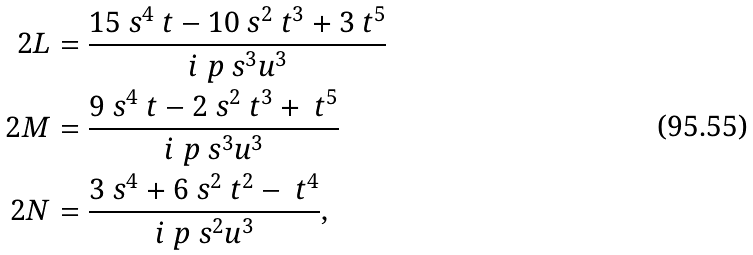Convert formula to latex. <formula><loc_0><loc_0><loc_500><loc_500>\ 2 L & = \frac { 1 5 \ s ^ { 4 } \ t - 1 0 \ s ^ { 2 } \ t ^ { 3 } + 3 \ t ^ { 5 } } { i \ p \ s ^ { 3 } u ^ { 3 } } \\ \ 2 M & = \frac { 9 \ s ^ { 4 } \ t - 2 \ s ^ { 2 } \ t ^ { 3 } + \ t ^ { 5 } } { i \ p \ s ^ { 3 } u ^ { 3 } } \\ \ 2 N & = \frac { 3 \ s ^ { 4 } + 6 \ s ^ { 2 } \ t ^ { 2 } - \ t ^ { 4 } } { i \ p \ s ^ { 2 } u ^ { 3 } } ,</formula> 